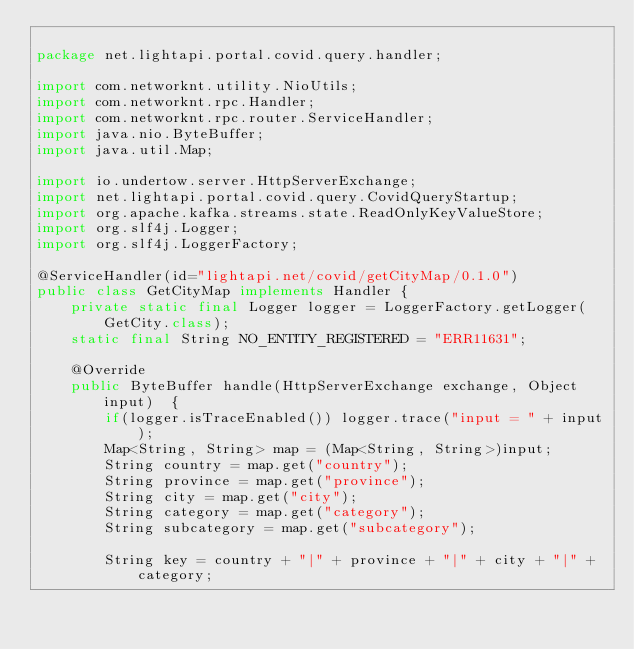<code> <loc_0><loc_0><loc_500><loc_500><_Java_>
package net.lightapi.portal.covid.query.handler;

import com.networknt.utility.NioUtils;
import com.networknt.rpc.Handler;
import com.networknt.rpc.router.ServiceHandler;
import java.nio.ByteBuffer;
import java.util.Map;

import io.undertow.server.HttpServerExchange;
import net.lightapi.portal.covid.query.CovidQueryStartup;
import org.apache.kafka.streams.state.ReadOnlyKeyValueStore;
import org.slf4j.Logger;
import org.slf4j.LoggerFactory;

@ServiceHandler(id="lightapi.net/covid/getCityMap/0.1.0")
public class GetCityMap implements Handler {
    private static final Logger logger = LoggerFactory.getLogger(GetCity.class);
    static final String NO_ENTITY_REGISTERED = "ERR11631";

    @Override
    public ByteBuffer handle(HttpServerExchange exchange, Object input)  {
        if(logger.isTraceEnabled()) logger.trace("input = " + input);
        Map<String, String> map = (Map<String, String>)input;
        String country = map.get("country");
        String province = map.get("province");
        String city = map.get("city");
        String category = map.get("category");
        String subcategory = map.get("subcategory");

        String key = country + "|" + province + "|" + city + "|" + category;</code> 